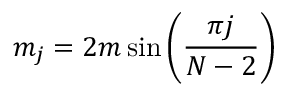<formula> <loc_0><loc_0><loc_500><loc_500>m _ { j } = 2 m \, { \sin \left ( \frac { \pi j } { N - 2 } \right ) }</formula> 